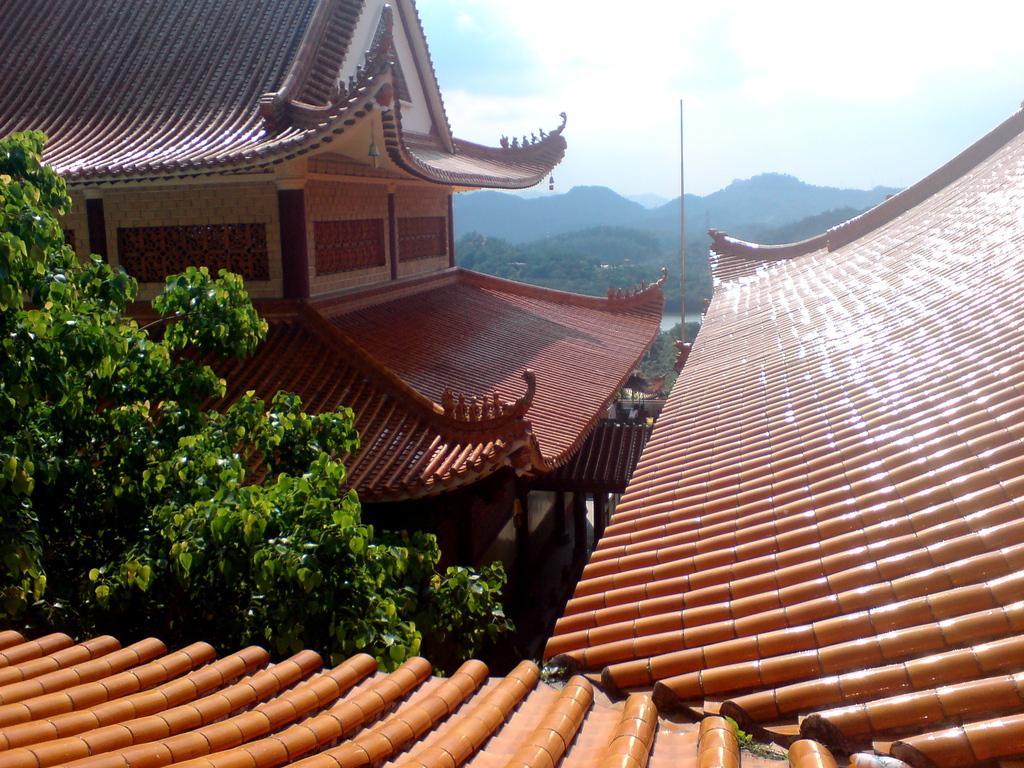In one or two sentences, can you explain what this image depicts? We can see rooftops, building and tree. In the background we can see pole, trees, hills and sky with clouds. 